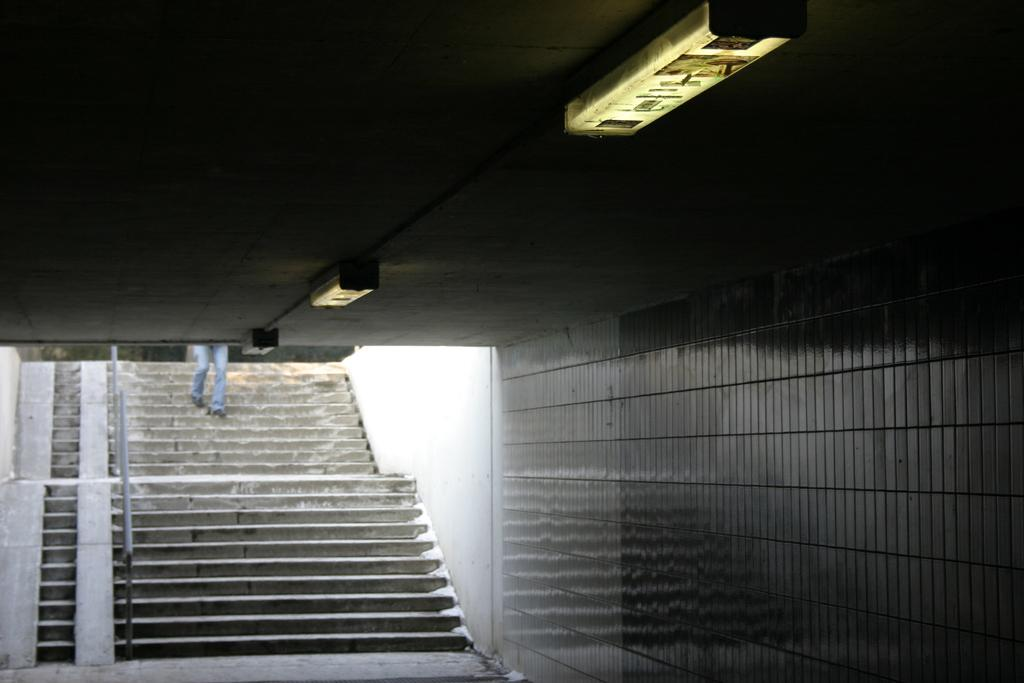What type of structure is present in the image? There is a building in the image. What can be seen illuminated in the image? There are lights visible in the image. What type of barrier is present in the image? There is a fence in the image. What architectural feature is present in the image? There is a staircase in the image. Who or what is present in the image? There is a person in the image. What type of vegetation is present in the image? There are trees in the image. What time of day was the image likely taken? The image was likely taken during the day, as there is no indication of darkness or artificial lighting. What type of cherry is being played by the person in the image? There is no cherry or musical instrument present in the image; it features a person near a building, fence, staircase, and trees. What type of ship can be seen sailing in the background of the image? There is no ship visible in the image; it features a person near a building, fence, staircase, and trees. 